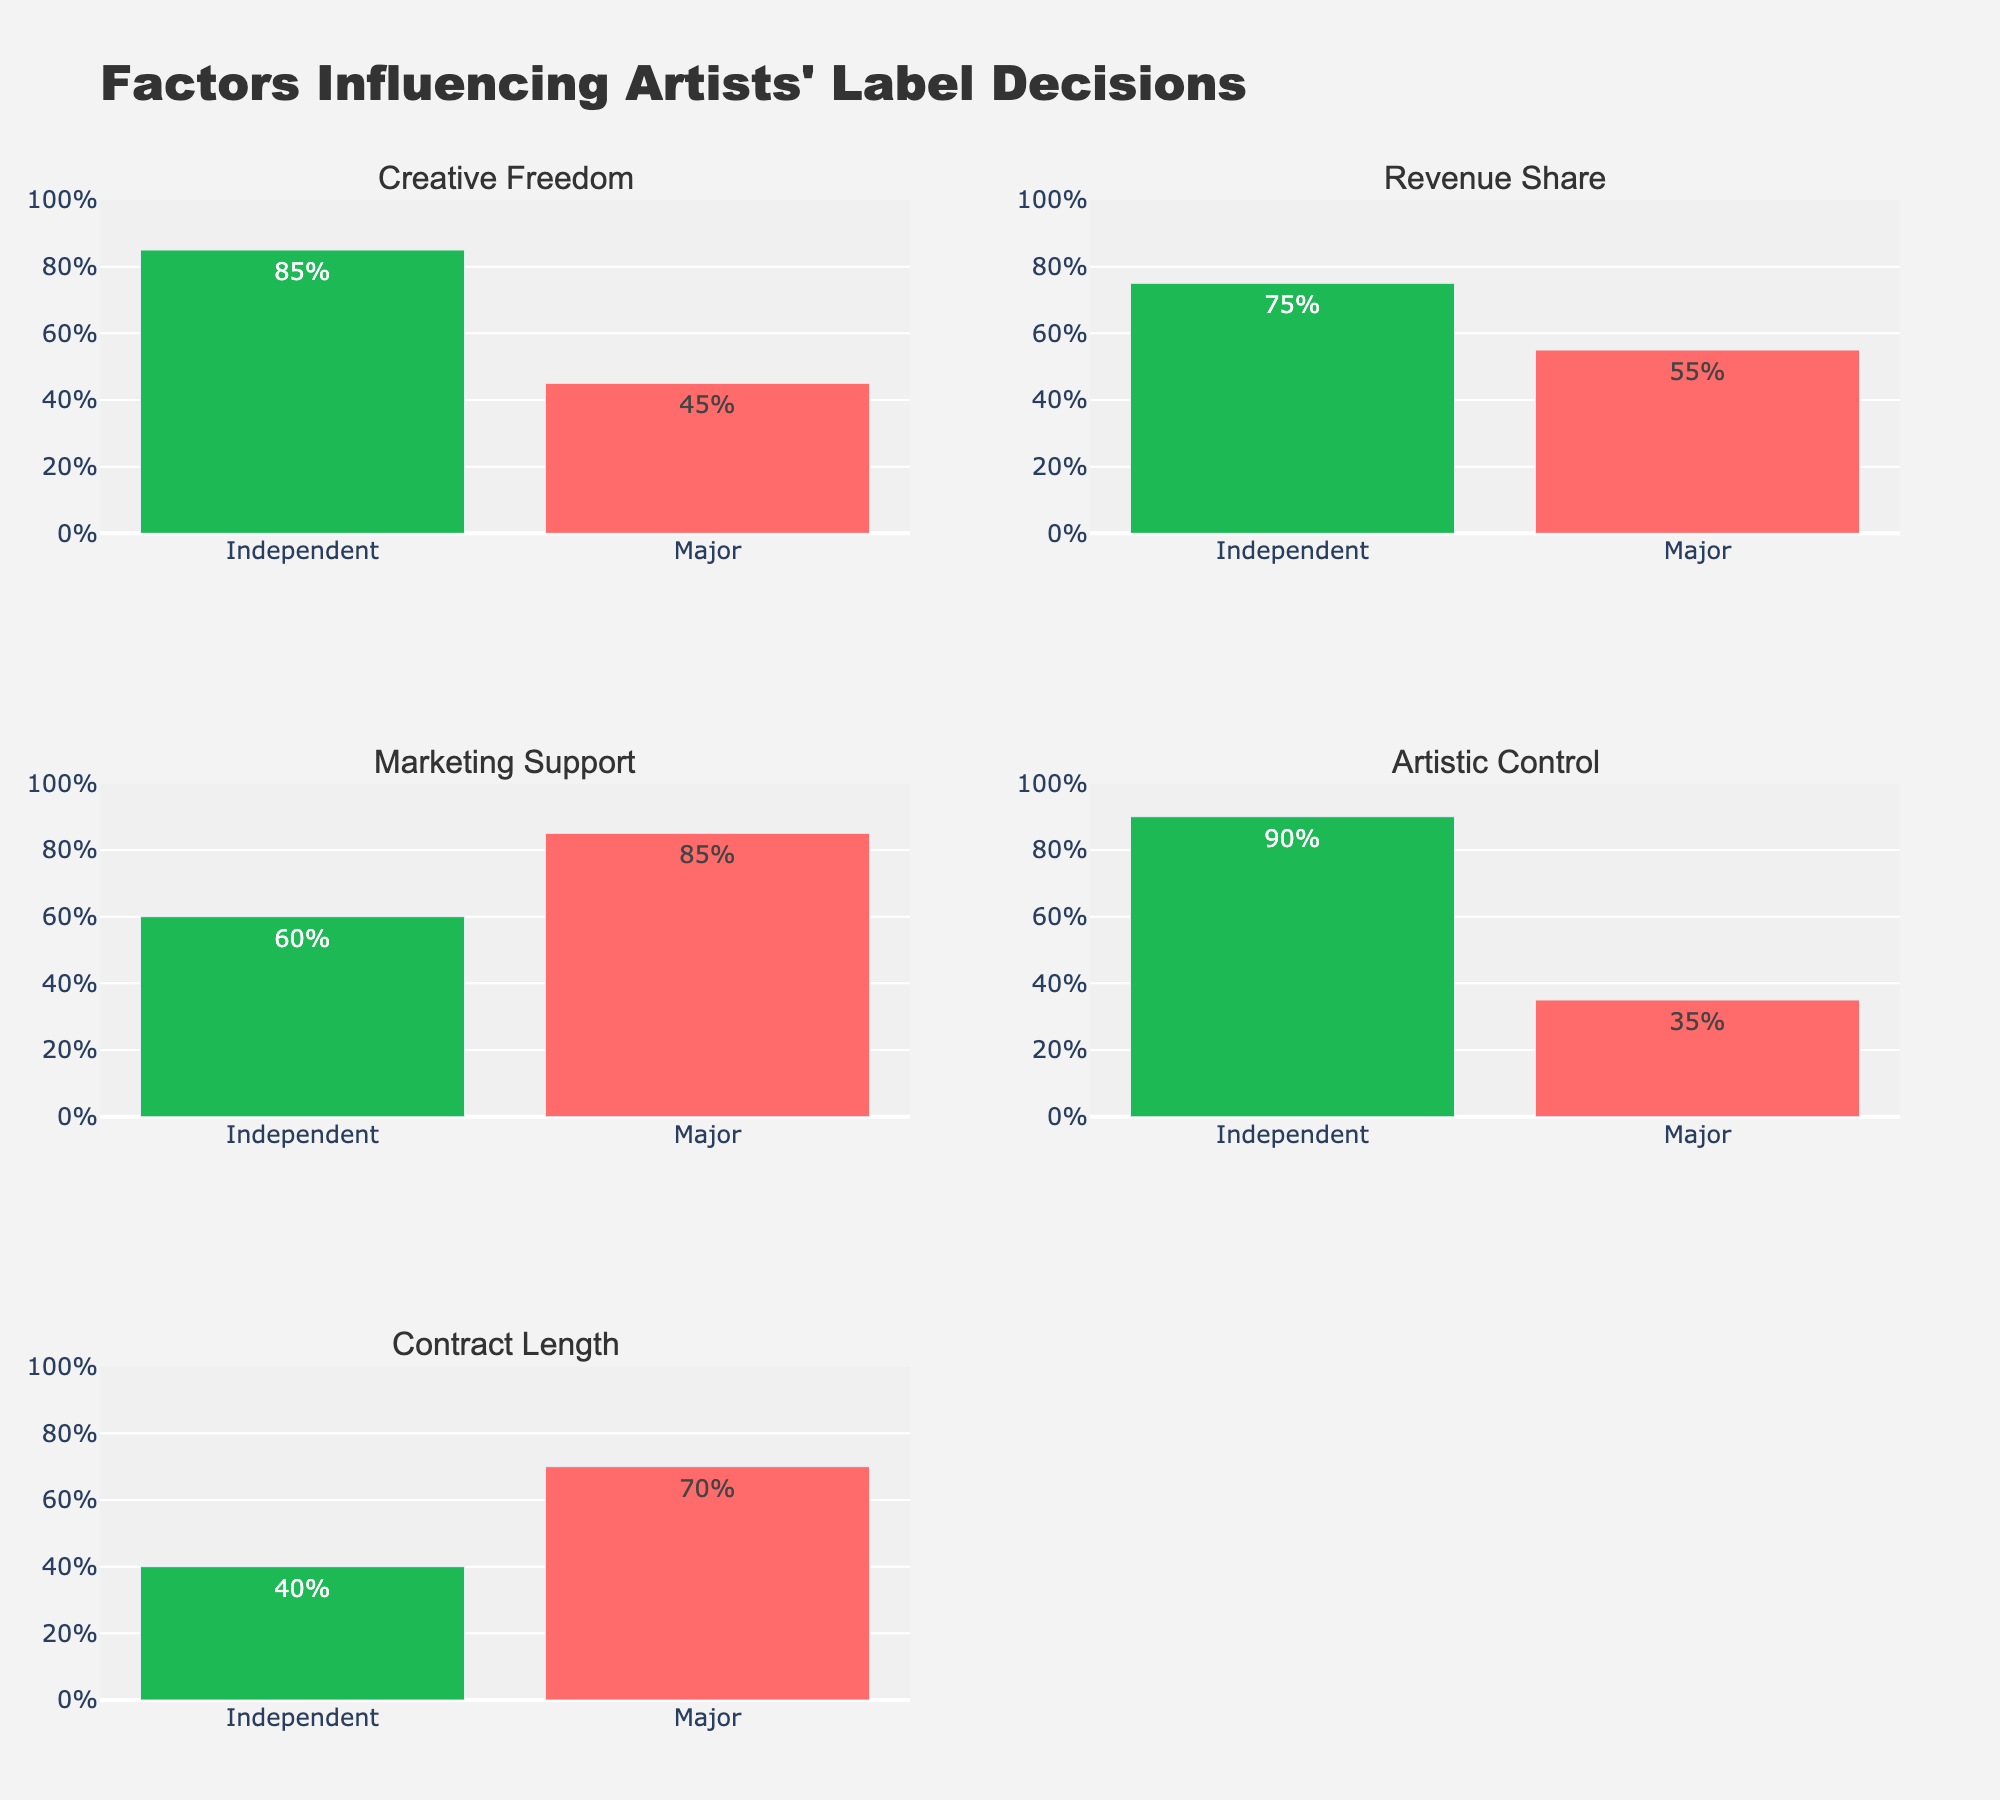What's the title of the figure? The title is located at the top of the figure. It provides a summary of what the figure is about. In this case, it reads "Factors Influencing Artists' Label Decisions".
Answer: Factors Influencing Artists' Label Decisions How many factors are compared between Independent Labels and Major Labels? Look at the subplot titles for each pair of bars. There are five different factors to compare.
Answer: Five What's the percentage value of Creative Freedom for Independent Labels? Locate the bar representing Creative Freedom under the Independent Labels. The height of the bar shows the percentage, and the text on the bar reads "85%".
Answer: 85% Which factor has the highest percentage for Major Labels? By observing the heights and the text of each bar under Major Labels, you'll see Marketing Support has the highest percentage, which is 85%.
Answer: Marketing Support What's the difference in percentage of Artistic Control between Independent Labels and Major Labels? Independent Labels have 90% Artistic Control while Major Labels have 35%. The difference is 90% - 35%.
Answer: 55% Which label type offers a longer Contract Length on average? Locate the Contract Length bars for both label types. Independent Labels offer 40% and Major Labels offer 70%. 70% is greater than 40%, indicating Major Labels offer longer contracts.
Answer: Major Labels For which factors do Independent Labels score higher than Major Labels? By comparing the heights and percentage values of each pair of bars, the factors where Independent Labels have higher scores are Creative Freedom, Revenue Share, and Artistic Control.
Answer: Creative Freedom, Revenue Share, Artistic Control Which factor shows the least percentage difference between Independent and Major Labels? Calculate the percentage difference for each factor and compare. Creative Freedom (85%-45% = 40%), Revenue Share (75%-55% = 20%), Marketing Support (60%-85% = -25%), Artistic Control (90%-35% = 55%), and Contract Length (40%-70% = -30%). The smallest difference is for Revenue Share (20%).
Answer: Revenue Share What's the average percentage of Marketing Support across both label types? Add the Marketing Support percentages for both labels (Independent: 60%, Major: 85%) and divide by 2. (60% + 85%) / 2 = 72.5%.
Answer: 72.5% Which factor shows the most significant preference for Independent Labels over Major Labels? Calculate the difference for each factor: Creative Freedom (85%-45%=40%), Revenue Share (75%-55%=20%), Marketing Support (60%-85%=-25%), Artistic Control (90%-35%=55%), and Contract Length (40%-70%=-30%). The highest positive difference is for Artistic Control (55%).
Answer: Artistic Control 